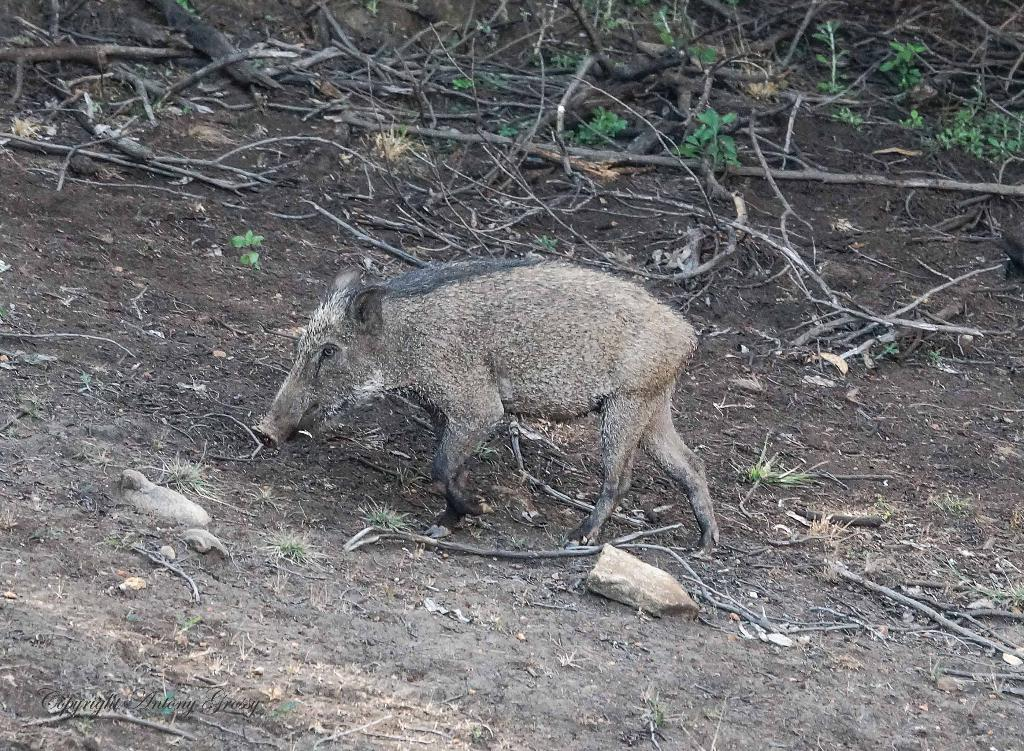What type of animal is in the image that resembles a pig? There is an animal in the image that resembles a pig, but it is not specified what kind of animal it is. What can be found at the bottom of the image? The bottom of the image contains soil, stones, grass, and twigs. What is visible in the background of the image? The background of the image includes twigs, herbs, and wooden sticks. What degree of difficulty is the animal attempting in the image? There is no indication of any difficulty or challenge in the image; it simply depicts an animal that resembles a pig in a particular setting. 